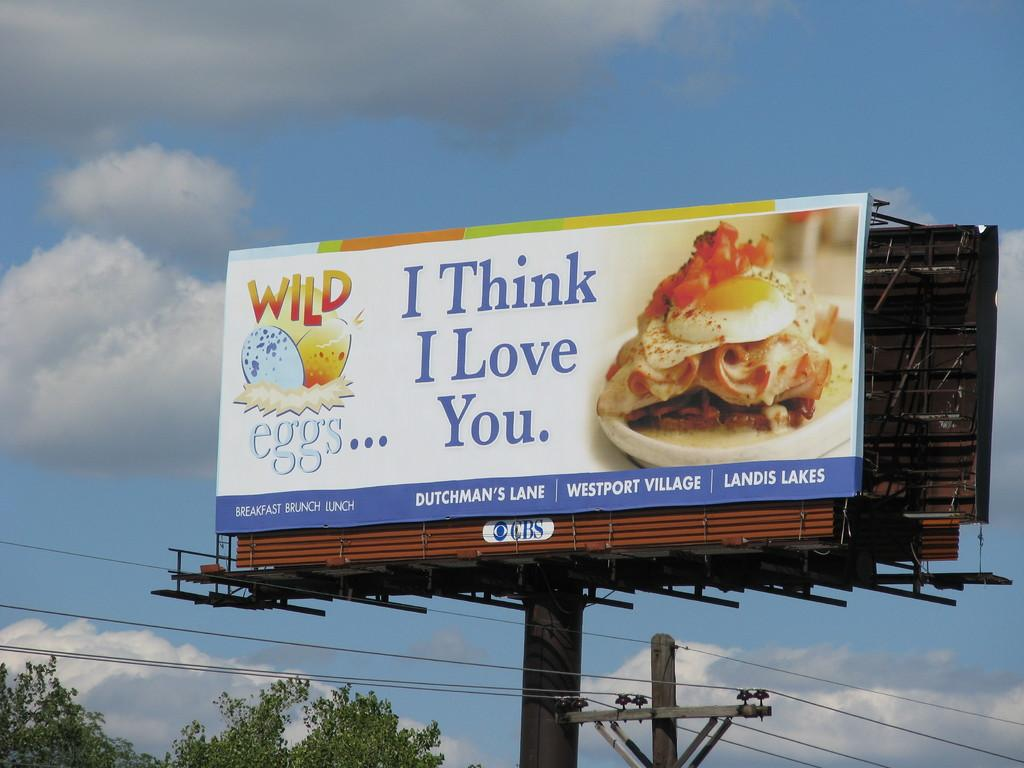Provide a one-sentence caption for the provided image. A large billboard says I Think I Love You. 